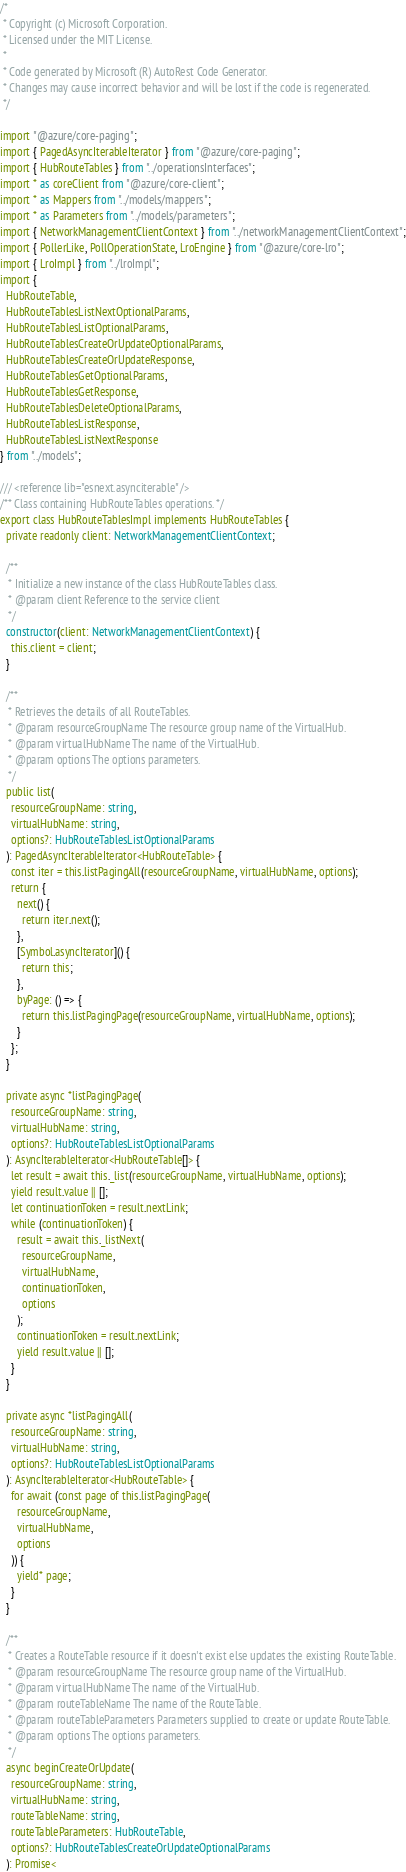<code> <loc_0><loc_0><loc_500><loc_500><_TypeScript_>/*
 * Copyright (c) Microsoft Corporation.
 * Licensed under the MIT License.
 *
 * Code generated by Microsoft (R) AutoRest Code Generator.
 * Changes may cause incorrect behavior and will be lost if the code is regenerated.
 */

import "@azure/core-paging";
import { PagedAsyncIterableIterator } from "@azure/core-paging";
import { HubRouteTables } from "../operationsInterfaces";
import * as coreClient from "@azure/core-client";
import * as Mappers from "../models/mappers";
import * as Parameters from "../models/parameters";
import { NetworkManagementClientContext } from "../networkManagementClientContext";
import { PollerLike, PollOperationState, LroEngine } from "@azure/core-lro";
import { LroImpl } from "../lroImpl";
import {
  HubRouteTable,
  HubRouteTablesListNextOptionalParams,
  HubRouteTablesListOptionalParams,
  HubRouteTablesCreateOrUpdateOptionalParams,
  HubRouteTablesCreateOrUpdateResponse,
  HubRouteTablesGetOptionalParams,
  HubRouteTablesGetResponse,
  HubRouteTablesDeleteOptionalParams,
  HubRouteTablesListResponse,
  HubRouteTablesListNextResponse
} from "../models";

/// <reference lib="esnext.asynciterable" />
/** Class containing HubRouteTables operations. */
export class HubRouteTablesImpl implements HubRouteTables {
  private readonly client: NetworkManagementClientContext;

  /**
   * Initialize a new instance of the class HubRouteTables class.
   * @param client Reference to the service client
   */
  constructor(client: NetworkManagementClientContext) {
    this.client = client;
  }

  /**
   * Retrieves the details of all RouteTables.
   * @param resourceGroupName The resource group name of the VirtualHub.
   * @param virtualHubName The name of the VirtualHub.
   * @param options The options parameters.
   */
  public list(
    resourceGroupName: string,
    virtualHubName: string,
    options?: HubRouteTablesListOptionalParams
  ): PagedAsyncIterableIterator<HubRouteTable> {
    const iter = this.listPagingAll(resourceGroupName, virtualHubName, options);
    return {
      next() {
        return iter.next();
      },
      [Symbol.asyncIterator]() {
        return this;
      },
      byPage: () => {
        return this.listPagingPage(resourceGroupName, virtualHubName, options);
      }
    };
  }

  private async *listPagingPage(
    resourceGroupName: string,
    virtualHubName: string,
    options?: HubRouteTablesListOptionalParams
  ): AsyncIterableIterator<HubRouteTable[]> {
    let result = await this._list(resourceGroupName, virtualHubName, options);
    yield result.value || [];
    let continuationToken = result.nextLink;
    while (continuationToken) {
      result = await this._listNext(
        resourceGroupName,
        virtualHubName,
        continuationToken,
        options
      );
      continuationToken = result.nextLink;
      yield result.value || [];
    }
  }

  private async *listPagingAll(
    resourceGroupName: string,
    virtualHubName: string,
    options?: HubRouteTablesListOptionalParams
  ): AsyncIterableIterator<HubRouteTable> {
    for await (const page of this.listPagingPage(
      resourceGroupName,
      virtualHubName,
      options
    )) {
      yield* page;
    }
  }

  /**
   * Creates a RouteTable resource if it doesn't exist else updates the existing RouteTable.
   * @param resourceGroupName The resource group name of the VirtualHub.
   * @param virtualHubName The name of the VirtualHub.
   * @param routeTableName The name of the RouteTable.
   * @param routeTableParameters Parameters supplied to create or update RouteTable.
   * @param options The options parameters.
   */
  async beginCreateOrUpdate(
    resourceGroupName: string,
    virtualHubName: string,
    routeTableName: string,
    routeTableParameters: HubRouteTable,
    options?: HubRouteTablesCreateOrUpdateOptionalParams
  ): Promise<</code> 